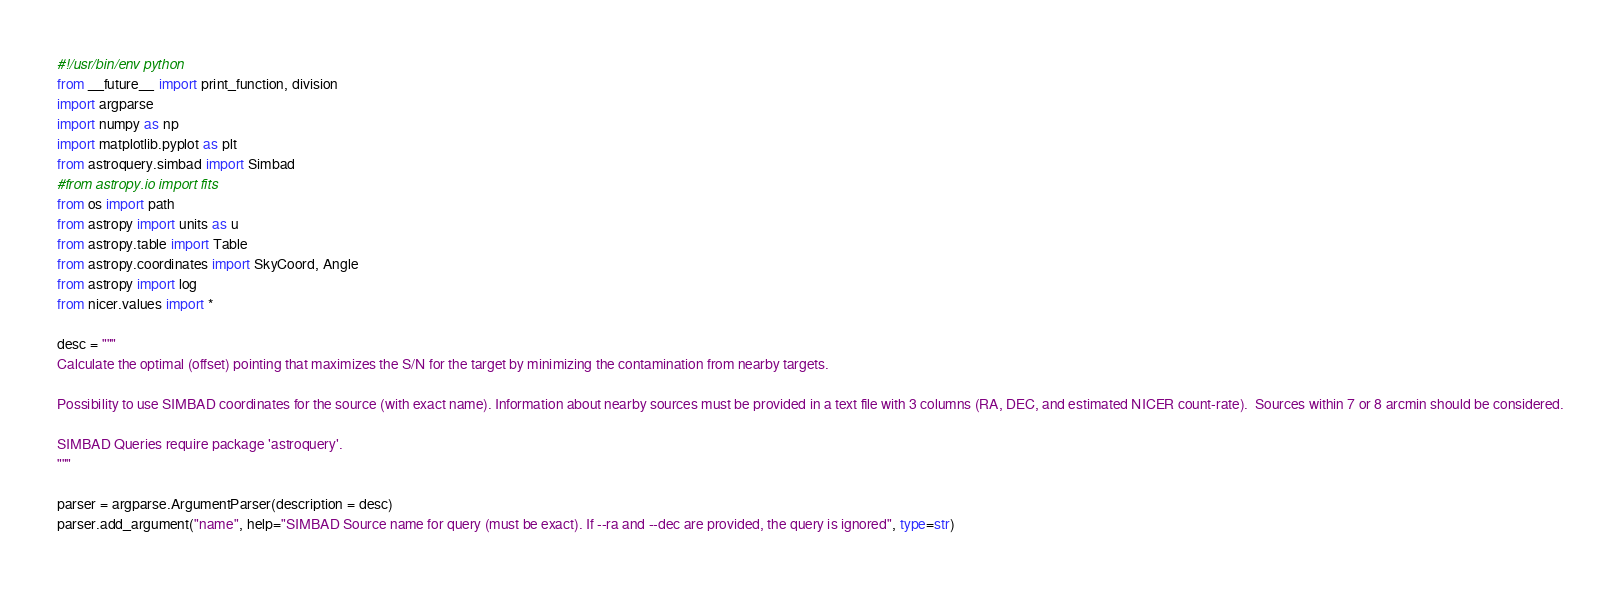Convert code to text. <code><loc_0><loc_0><loc_500><loc_500><_Python_>#!/usr/bin/env python
from __future__ import print_function, division
import argparse
import numpy as np
import matplotlib.pyplot as plt
from astroquery.simbad import Simbad
#from astropy.io import fits
from os import path
from astropy import units as u
from astropy.table import Table
from astropy.coordinates import SkyCoord, Angle
from astropy import log
from nicer.values import *

desc = """
Calculate the optimal (offset) pointing that maximizes the S/N for the target by minimizing the contamination from nearby targets.

Possibility to use SIMBAD coordinates for the source (with exact name). Information about nearby sources must be provided in a text file with 3 columns (RA, DEC, and estimated NICER count-rate).  Sources within 7 or 8 arcmin should be considered.

SIMBAD Queries require package 'astroquery'.
"""

parser = argparse.ArgumentParser(description = desc)
parser.add_argument("name", help="SIMBAD Source name for query (must be exact). If --ra and --dec are provided, the query is ignored", type=str)</code> 